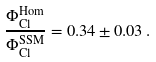<formula> <loc_0><loc_0><loc_500><loc_500>\frac { \Phi _ { \text {Cl} } ^ { \text {Hom} } } { \Phi _ { \text {Cl} } ^ { \text {SSM} } } = 0 . 3 4 \pm 0 . 0 3 \, .</formula> 